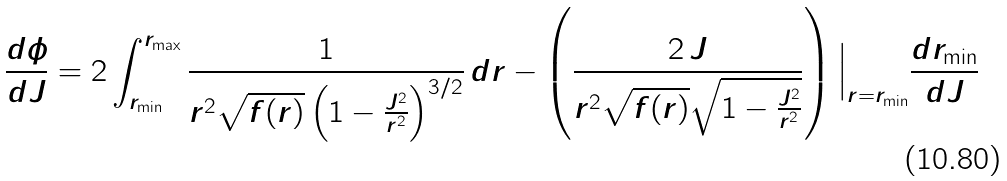Convert formula to latex. <formula><loc_0><loc_0><loc_500><loc_500>\frac { d \phi } { d J } = 2 \int _ { r _ { \min } } ^ { r _ { \max } } \frac { 1 } { r ^ { 2 } \sqrt { f ( r ) } \left ( 1 - \frac { J ^ { 2 } } { r ^ { 2 } } \right ) ^ { 3 / 2 } } \, d r - \left ( \frac { 2 \, J } { r ^ { 2 } \sqrt { f ( r ) } \sqrt { 1 - \frac { J ^ { 2 } } { r ^ { 2 } } } } \right ) \Big | _ { r = r _ { \min } } \frac { d r _ { \min } } { d J }</formula> 